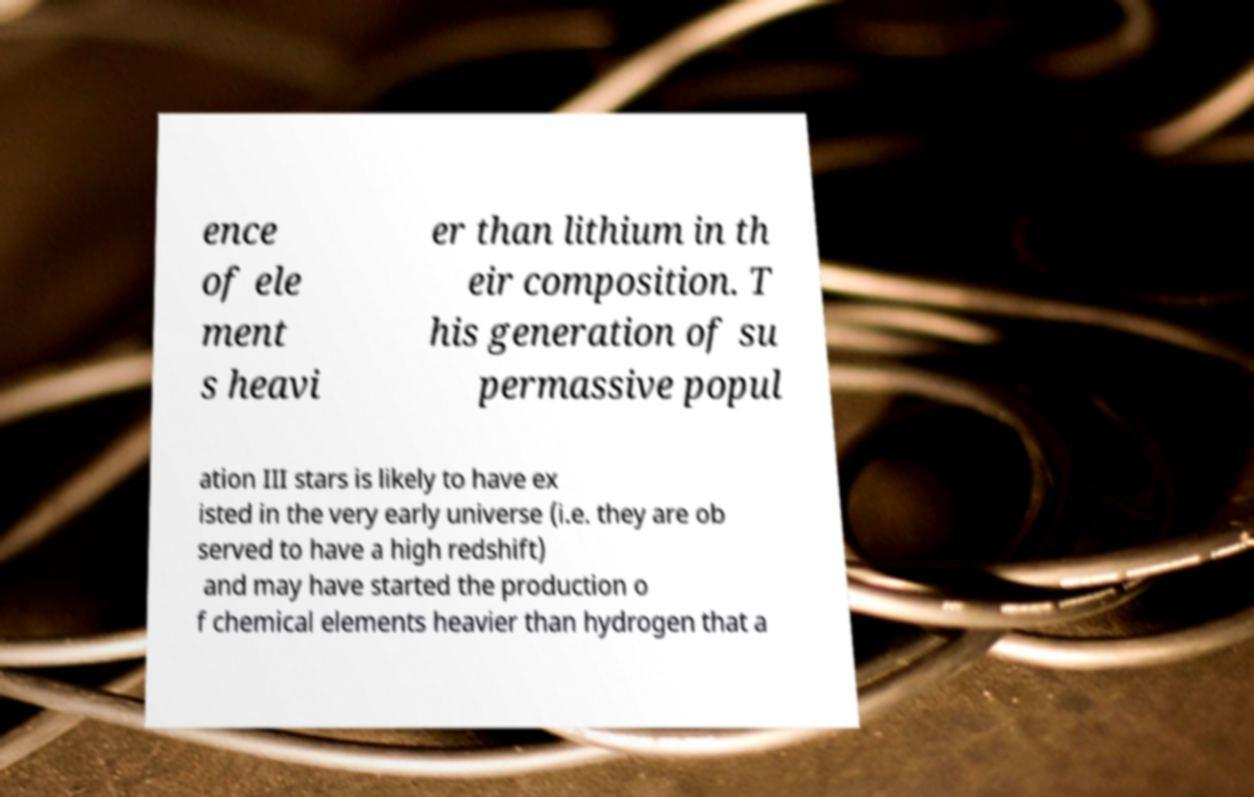Please identify and transcribe the text found in this image. ence of ele ment s heavi er than lithium in th eir composition. T his generation of su permassive popul ation III stars is likely to have ex isted in the very early universe (i.e. they are ob served to have a high redshift) and may have started the production o f chemical elements heavier than hydrogen that a 